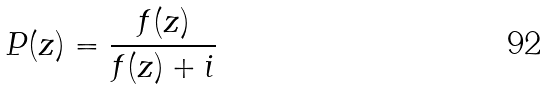Convert formula to latex. <formula><loc_0><loc_0><loc_500><loc_500>P ( z ) = \frac { f ( z ) } { f ( z ) + i }</formula> 